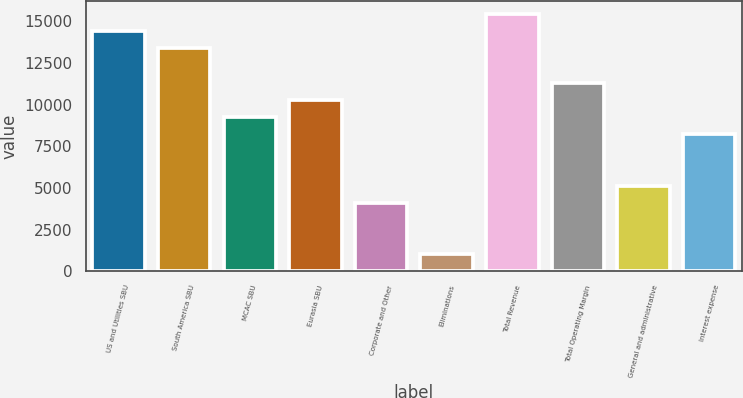Convert chart. <chart><loc_0><loc_0><loc_500><loc_500><bar_chart><fcel>US and Utilities SBU<fcel>South America SBU<fcel>MCAC SBU<fcel>Eurasia SBU<fcel>Corporate and Other<fcel>Eliminations<fcel>Total Revenue<fcel>Total Operating Margin<fcel>General and administrative<fcel>Interest expense<nl><fcel>14393.2<fcel>13365.2<fcel>9252.97<fcel>10281<fcel>4112.68<fcel>1028.51<fcel>15421.3<fcel>11309.1<fcel>5140.74<fcel>8224.91<nl></chart> 